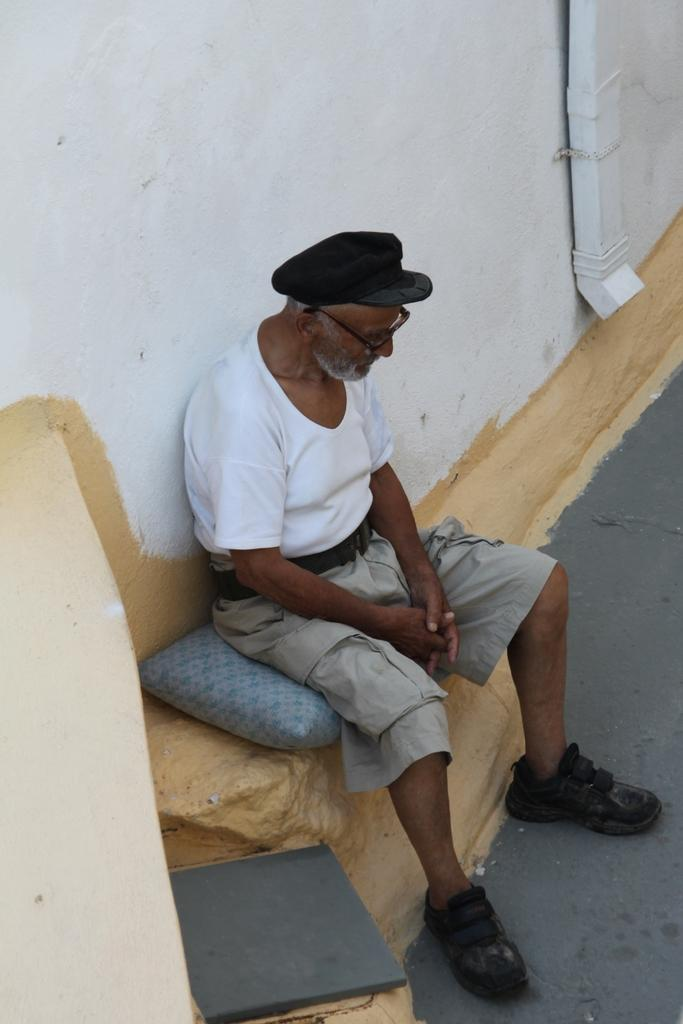What is the main subject of the image? There is a person sitting in the image. Can you describe the background of the image? There is a wall in the background of the image. What type of flag is being waved by the girl in the image? There is no girl or flag present in the image; it only features a person sitting and a wall in the background. 